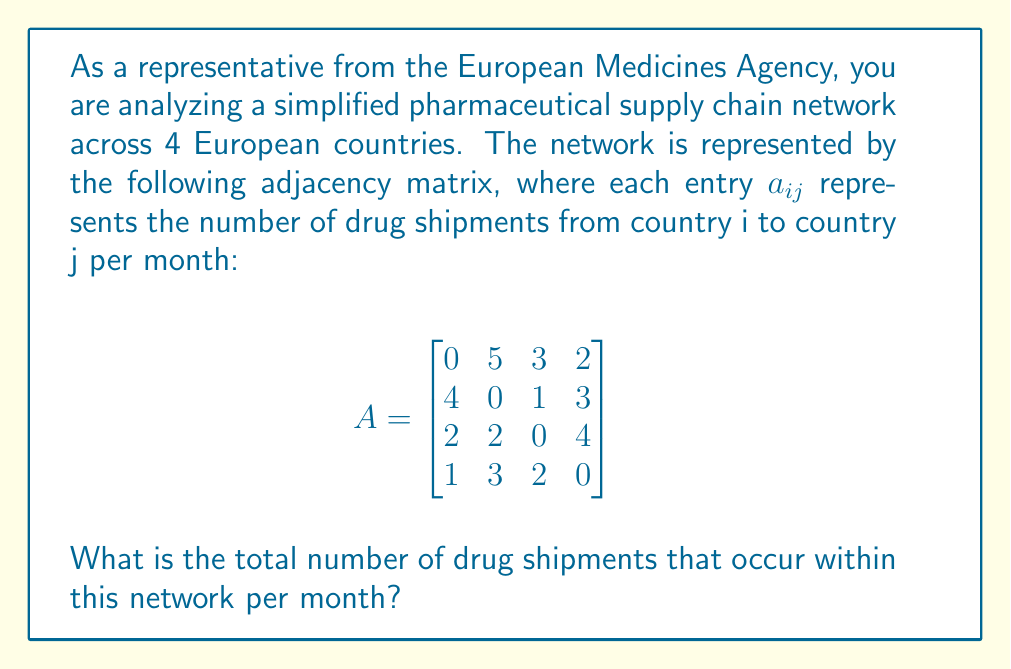Help me with this question. To solve this problem, we need to sum all the entries in the adjacency matrix, excluding the diagonal (which represents shipments within the same country and is always 0 in this case).

Let's break it down step-by-step:

1) First row: $5 + 3 + 2 = 10$
2) Second row: $4 + 1 + 3 = 8$
3) Third row: $2 + 2 + 4 = 8$
4) Fourth row: $1 + 3 + 2 = 6$

Now, we sum these totals:

$10 + 8 + 8 + 6 = 32$

Alternatively, we could have summed all non-zero entries in the matrix:

$5 + 3 + 2 + 4 + 1 + 3 + 2 + 2 + 4 + 1 + 3 + 2 = 32$

Therefore, the total number of drug shipments occurring within this network per month is 32.
Answer: 32 shipments 